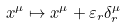<formula> <loc_0><loc_0><loc_500><loc_500>x ^ { \mu } \mapsto x ^ { \mu } + \varepsilon _ { r } \delta _ { r } ^ { \mu }</formula> 